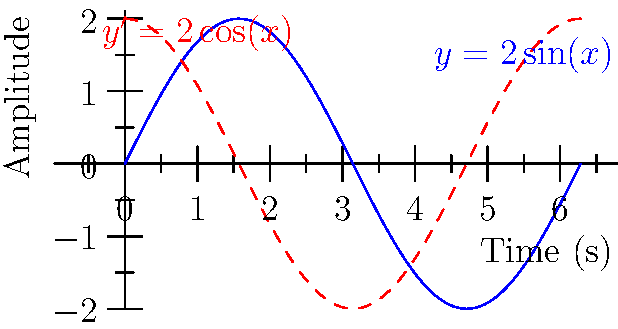As a DJ, you're analyzing the sound waves of a popular merengue track. The amplitude of the sound wave over time can be modeled by the function $y = 2\sin(x)$, where $y$ represents the amplitude in decibels and $x$ represents time in seconds. At what point in the first cycle does the rate of change in amplitude reach its maximum value, and what is this maximum rate of change? To solve this problem, we need to follow these steps:

1) The rate of change of the amplitude is given by the derivative of the function. For $y = 2\sin(x)$, the derivative is:

   $y' = 2\cos(x)$

2) The maximum rate of change occurs when $\cos(x)$ reaches its maximum value of 1 or minimum value of -1.

3) In the first cycle (0 to $2\pi$), $\cos(x)$ reaches its maximum value of 1 when $x = 0$.

4) At this point, the rate of change is:

   $y' = 2\cos(0) = 2(1) = 2$

5) Therefore, the maximum rate of change is 2 decibels per second, occurring at the beginning of the cycle (when $x = 0$).

6) It's worth noting that the minimum rate of change (-2 decibels per second) occurs at $x = \pi$, halfway through the cycle.
Answer: At $x = 0$, with a maximum rate of change of 2 dB/s. 